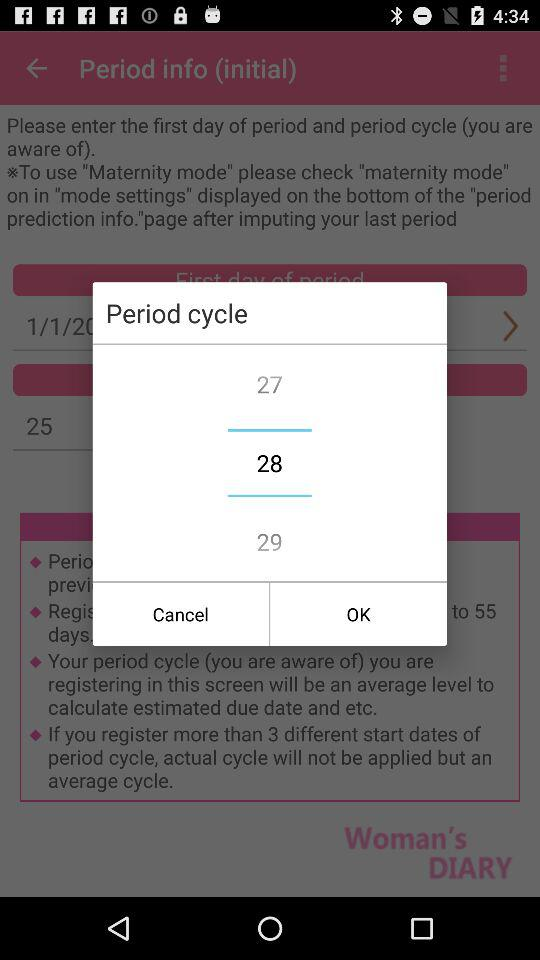How to use "Maternity mode"? To use "Maternity mode", please check that "maternity mode" is "on" in the "mode settings" displayed on the "period prediction info". 